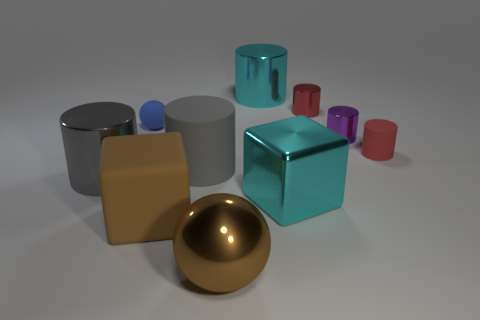There is a rubber thing that is on the left side of the big block that is to the left of the cube behind the big brown rubber block; what is its shape?
Your response must be concise. Sphere. What is the material of the cylinder that is both to the left of the cyan cube and behind the tiny blue thing?
Offer a very short reply. Metal. The big cylinder in front of the gray cylinder that is on the right side of the large metal cylinder that is in front of the blue rubber thing is what color?
Give a very brief answer. Gray. How many gray things are either small matte balls or big matte cylinders?
Make the answer very short. 1. How many other things are the same size as the purple cylinder?
Keep it short and to the point. 3. What number of small purple rubber blocks are there?
Give a very brief answer. 0. Is there any other thing that is the same shape as the red matte thing?
Give a very brief answer. Yes. Is the gray thing left of the big brown matte object made of the same material as the brown object that is in front of the brown block?
Provide a succinct answer. Yes. What material is the tiny sphere?
Your response must be concise. Rubber. What number of large brown cubes have the same material as the blue object?
Make the answer very short. 1. 